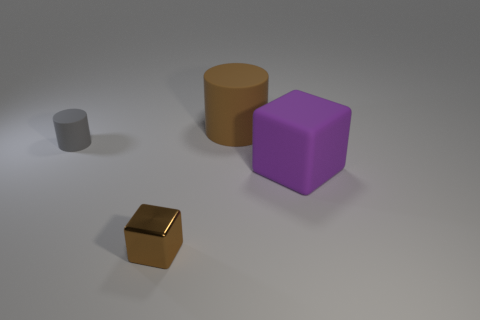Add 2 big rubber cylinders. How many objects exist? 6 Add 1 brown objects. How many brown objects exist? 3 Subtract 0 cyan spheres. How many objects are left? 4 Subtract all tiny things. Subtract all small gray objects. How many objects are left? 1 Add 4 large brown things. How many large brown things are left? 5 